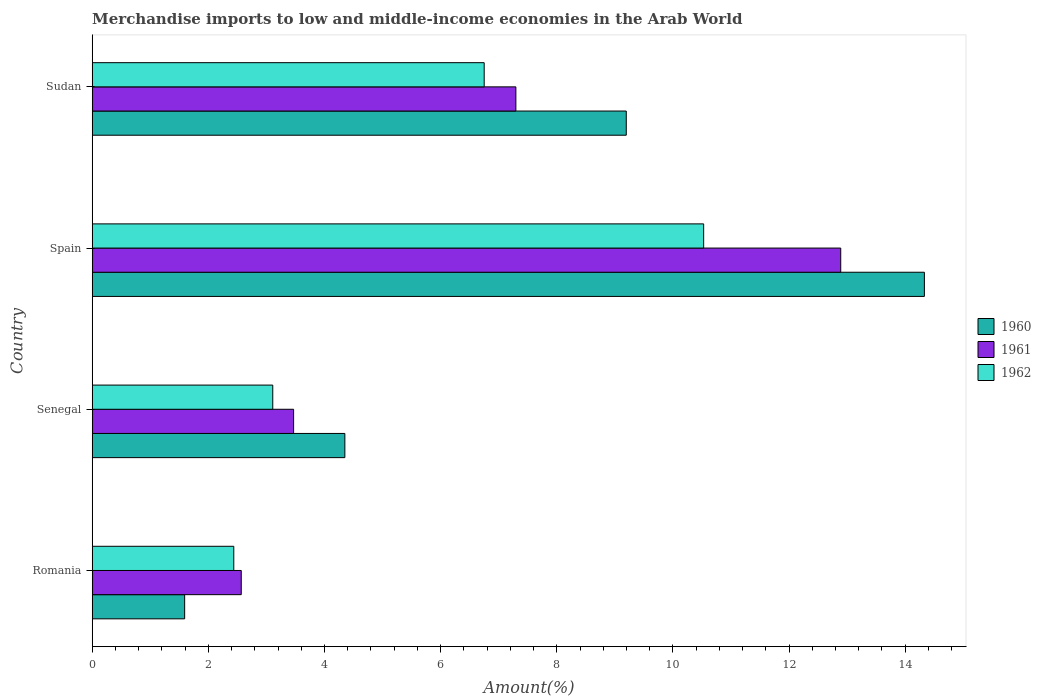How many different coloured bars are there?
Your answer should be very brief. 3. How many groups of bars are there?
Your answer should be compact. 4. Are the number of bars on each tick of the Y-axis equal?
Offer a terse response. Yes. How many bars are there on the 3rd tick from the top?
Provide a short and direct response. 3. What is the label of the 3rd group of bars from the top?
Offer a very short reply. Senegal. What is the percentage of amount earned from merchandise imports in 1962 in Romania?
Your response must be concise. 2.44. Across all countries, what is the maximum percentage of amount earned from merchandise imports in 1961?
Make the answer very short. 12.89. Across all countries, what is the minimum percentage of amount earned from merchandise imports in 1960?
Offer a terse response. 1.59. In which country was the percentage of amount earned from merchandise imports in 1960 minimum?
Ensure brevity in your answer.  Romania. What is the total percentage of amount earned from merchandise imports in 1962 in the graph?
Offer a terse response. 22.83. What is the difference between the percentage of amount earned from merchandise imports in 1961 in Senegal and that in Sudan?
Offer a terse response. -3.83. What is the difference between the percentage of amount earned from merchandise imports in 1960 in Spain and the percentage of amount earned from merchandise imports in 1962 in Senegal?
Ensure brevity in your answer.  11.22. What is the average percentage of amount earned from merchandise imports in 1961 per country?
Your response must be concise. 6.55. What is the difference between the percentage of amount earned from merchandise imports in 1962 and percentage of amount earned from merchandise imports in 1961 in Spain?
Your answer should be compact. -2.36. In how many countries, is the percentage of amount earned from merchandise imports in 1960 greater than 12.4 %?
Offer a very short reply. 1. What is the ratio of the percentage of amount earned from merchandise imports in 1960 in Senegal to that in Spain?
Make the answer very short. 0.3. What is the difference between the highest and the second highest percentage of amount earned from merchandise imports in 1961?
Provide a succinct answer. 5.59. What is the difference between the highest and the lowest percentage of amount earned from merchandise imports in 1962?
Provide a succinct answer. 8.09. In how many countries, is the percentage of amount earned from merchandise imports in 1962 greater than the average percentage of amount earned from merchandise imports in 1962 taken over all countries?
Ensure brevity in your answer.  2. Is it the case that in every country, the sum of the percentage of amount earned from merchandise imports in 1962 and percentage of amount earned from merchandise imports in 1960 is greater than the percentage of amount earned from merchandise imports in 1961?
Make the answer very short. Yes. Are all the bars in the graph horizontal?
Your response must be concise. Yes. Are the values on the major ticks of X-axis written in scientific E-notation?
Provide a succinct answer. No. Does the graph contain grids?
Your answer should be very brief. No. What is the title of the graph?
Provide a succinct answer. Merchandise imports to low and middle-income economies in the Arab World. What is the label or title of the X-axis?
Your response must be concise. Amount(%). What is the label or title of the Y-axis?
Provide a succinct answer. Country. What is the Amount(%) in 1960 in Romania?
Provide a succinct answer. 1.59. What is the Amount(%) of 1961 in Romania?
Your response must be concise. 2.57. What is the Amount(%) of 1962 in Romania?
Give a very brief answer. 2.44. What is the Amount(%) of 1960 in Senegal?
Ensure brevity in your answer.  4.35. What is the Amount(%) in 1961 in Senegal?
Your response must be concise. 3.47. What is the Amount(%) in 1962 in Senegal?
Your response must be concise. 3.11. What is the Amount(%) in 1960 in Spain?
Provide a succinct answer. 14.33. What is the Amount(%) in 1961 in Spain?
Ensure brevity in your answer.  12.89. What is the Amount(%) of 1962 in Spain?
Your answer should be very brief. 10.53. What is the Amount(%) in 1960 in Sudan?
Keep it short and to the point. 9.2. What is the Amount(%) in 1961 in Sudan?
Offer a very short reply. 7.3. What is the Amount(%) of 1962 in Sudan?
Your answer should be compact. 6.75. Across all countries, what is the maximum Amount(%) of 1960?
Keep it short and to the point. 14.33. Across all countries, what is the maximum Amount(%) in 1961?
Your answer should be compact. 12.89. Across all countries, what is the maximum Amount(%) of 1962?
Ensure brevity in your answer.  10.53. Across all countries, what is the minimum Amount(%) in 1960?
Provide a short and direct response. 1.59. Across all countries, what is the minimum Amount(%) in 1961?
Make the answer very short. 2.57. Across all countries, what is the minimum Amount(%) of 1962?
Offer a very short reply. 2.44. What is the total Amount(%) in 1960 in the graph?
Give a very brief answer. 29.47. What is the total Amount(%) in 1961 in the graph?
Provide a short and direct response. 26.22. What is the total Amount(%) in 1962 in the graph?
Give a very brief answer. 22.83. What is the difference between the Amount(%) in 1960 in Romania and that in Senegal?
Provide a succinct answer. -2.76. What is the difference between the Amount(%) in 1961 in Romania and that in Senegal?
Your answer should be very brief. -0.9. What is the difference between the Amount(%) of 1962 in Romania and that in Senegal?
Offer a very short reply. -0.67. What is the difference between the Amount(%) of 1960 in Romania and that in Spain?
Your answer should be very brief. -12.74. What is the difference between the Amount(%) of 1961 in Romania and that in Spain?
Your response must be concise. -10.32. What is the difference between the Amount(%) in 1962 in Romania and that in Spain?
Ensure brevity in your answer.  -8.09. What is the difference between the Amount(%) of 1960 in Romania and that in Sudan?
Ensure brevity in your answer.  -7.61. What is the difference between the Amount(%) of 1961 in Romania and that in Sudan?
Ensure brevity in your answer.  -4.73. What is the difference between the Amount(%) of 1962 in Romania and that in Sudan?
Provide a succinct answer. -4.31. What is the difference between the Amount(%) of 1960 in Senegal and that in Spain?
Give a very brief answer. -9.98. What is the difference between the Amount(%) of 1961 in Senegal and that in Spain?
Your response must be concise. -9.42. What is the difference between the Amount(%) in 1962 in Senegal and that in Spain?
Offer a very short reply. -7.42. What is the difference between the Amount(%) of 1960 in Senegal and that in Sudan?
Give a very brief answer. -4.85. What is the difference between the Amount(%) of 1961 in Senegal and that in Sudan?
Your answer should be very brief. -3.83. What is the difference between the Amount(%) in 1962 in Senegal and that in Sudan?
Ensure brevity in your answer.  -3.64. What is the difference between the Amount(%) in 1960 in Spain and that in Sudan?
Your response must be concise. 5.13. What is the difference between the Amount(%) of 1961 in Spain and that in Sudan?
Ensure brevity in your answer.  5.59. What is the difference between the Amount(%) of 1962 in Spain and that in Sudan?
Ensure brevity in your answer.  3.78. What is the difference between the Amount(%) of 1960 in Romania and the Amount(%) of 1961 in Senegal?
Give a very brief answer. -1.88. What is the difference between the Amount(%) of 1960 in Romania and the Amount(%) of 1962 in Senegal?
Your response must be concise. -1.52. What is the difference between the Amount(%) of 1961 in Romania and the Amount(%) of 1962 in Senegal?
Provide a short and direct response. -0.54. What is the difference between the Amount(%) in 1960 in Romania and the Amount(%) in 1961 in Spain?
Offer a very short reply. -11.3. What is the difference between the Amount(%) of 1960 in Romania and the Amount(%) of 1962 in Spain?
Your answer should be very brief. -8.94. What is the difference between the Amount(%) of 1961 in Romania and the Amount(%) of 1962 in Spain?
Offer a very short reply. -7.96. What is the difference between the Amount(%) in 1960 in Romania and the Amount(%) in 1961 in Sudan?
Ensure brevity in your answer.  -5.7. What is the difference between the Amount(%) in 1960 in Romania and the Amount(%) in 1962 in Sudan?
Provide a short and direct response. -5.16. What is the difference between the Amount(%) of 1961 in Romania and the Amount(%) of 1962 in Sudan?
Offer a very short reply. -4.18. What is the difference between the Amount(%) of 1960 in Senegal and the Amount(%) of 1961 in Spain?
Provide a short and direct response. -8.54. What is the difference between the Amount(%) in 1960 in Senegal and the Amount(%) in 1962 in Spain?
Give a very brief answer. -6.18. What is the difference between the Amount(%) of 1961 in Senegal and the Amount(%) of 1962 in Spain?
Make the answer very short. -7.06. What is the difference between the Amount(%) in 1960 in Senegal and the Amount(%) in 1961 in Sudan?
Your answer should be compact. -2.95. What is the difference between the Amount(%) in 1960 in Senegal and the Amount(%) in 1962 in Sudan?
Your response must be concise. -2.4. What is the difference between the Amount(%) in 1961 in Senegal and the Amount(%) in 1962 in Sudan?
Keep it short and to the point. -3.28. What is the difference between the Amount(%) in 1960 in Spain and the Amount(%) in 1961 in Sudan?
Offer a terse response. 7.03. What is the difference between the Amount(%) in 1960 in Spain and the Amount(%) in 1962 in Sudan?
Offer a terse response. 7.58. What is the difference between the Amount(%) of 1961 in Spain and the Amount(%) of 1962 in Sudan?
Ensure brevity in your answer.  6.14. What is the average Amount(%) of 1960 per country?
Keep it short and to the point. 7.37. What is the average Amount(%) of 1961 per country?
Provide a succinct answer. 6.55. What is the average Amount(%) of 1962 per country?
Keep it short and to the point. 5.71. What is the difference between the Amount(%) of 1960 and Amount(%) of 1961 in Romania?
Give a very brief answer. -0.97. What is the difference between the Amount(%) in 1960 and Amount(%) in 1962 in Romania?
Offer a very short reply. -0.85. What is the difference between the Amount(%) in 1961 and Amount(%) in 1962 in Romania?
Offer a very short reply. 0.13. What is the difference between the Amount(%) in 1960 and Amount(%) in 1961 in Senegal?
Your response must be concise. 0.88. What is the difference between the Amount(%) in 1960 and Amount(%) in 1962 in Senegal?
Give a very brief answer. 1.24. What is the difference between the Amount(%) of 1961 and Amount(%) of 1962 in Senegal?
Make the answer very short. 0.36. What is the difference between the Amount(%) of 1960 and Amount(%) of 1961 in Spain?
Provide a succinct answer. 1.44. What is the difference between the Amount(%) in 1960 and Amount(%) in 1962 in Spain?
Make the answer very short. 3.8. What is the difference between the Amount(%) in 1961 and Amount(%) in 1962 in Spain?
Offer a terse response. 2.36. What is the difference between the Amount(%) of 1960 and Amount(%) of 1961 in Sudan?
Your response must be concise. 1.9. What is the difference between the Amount(%) of 1960 and Amount(%) of 1962 in Sudan?
Ensure brevity in your answer.  2.45. What is the difference between the Amount(%) in 1961 and Amount(%) in 1962 in Sudan?
Offer a terse response. 0.55. What is the ratio of the Amount(%) of 1960 in Romania to that in Senegal?
Your response must be concise. 0.37. What is the ratio of the Amount(%) of 1961 in Romania to that in Senegal?
Your answer should be very brief. 0.74. What is the ratio of the Amount(%) of 1962 in Romania to that in Senegal?
Give a very brief answer. 0.78. What is the ratio of the Amount(%) in 1961 in Romania to that in Spain?
Provide a short and direct response. 0.2. What is the ratio of the Amount(%) of 1962 in Romania to that in Spain?
Your answer should be compact. 0.23. What is the ratio of the Amount(%) of 1960 in Romania to that in Sudan?
Offer a terse response. 0.17. What is the ratio of the Amount(%) in 1961 in Romania to that in Sudan?
Your answer should be very brief. 0.35. What is the ratio of the Amount(%) of 1962 in Romania to that in Sudan?
Provide a short and direct response. 0.36. What is the ratio of the Amount(%) of 1960 in Senegal to that in Spain?
Give a very brief answer. 0.3. What is the ratio of the Amount(%) in 1961 in Senegal to that in Spain?
Offer a very short reply. 0.27. What is the ratio of the Amount(%) in 1962 in Senegal to that in Spain?
Provide a short and direct response. 0.3. What is the ratio of the Amount(%) in 1960 in Senegal to that in Sudan?
Give a very brief answer. 0.47. What is the ratio of the Amount(%) of 1961 in Senegal to that in Sudan?
Your answer should be very brief. 0.48. What is the ratio of the Amount(%) of 1962 in Senegal to that in Sudan?
Make the answer very short. 0.46. What is the ratio of the Amount(%) of 1960 in Spain to that in Sudan?
Your response must be concise. 1.56. What is the ratio of the Amount(%) of 1961 in Spain to that in Sudan?
Offer a very short reply. 1.77. What is the ratio of the Amount(%) of 1962 in Spain to that in Sudan?
Offer a very short reply. 1.56. What is the difference between the highest and the second highest Amount(%) of 1960?
Give a very brief answer. 5.13. What is the difference between the highest and the second highest Amount(%) of 1961?
Offer a terse response. 5.59. What is the difference between the highest and the second highest Amount(%) in 1962?
Provide a succinct answer. 3.78. What is the difference between the highest and the lowest Amount(%) of 1960?
Ensure brevity in your answer.  12.74. What is the difference between the highest and the lowest Amount(%) of 1961?
Offer a terse response. 10.32. What is the difference between the highest and the lowest Amount(%) of 1962?
Offer a very short reply. 8.09. 